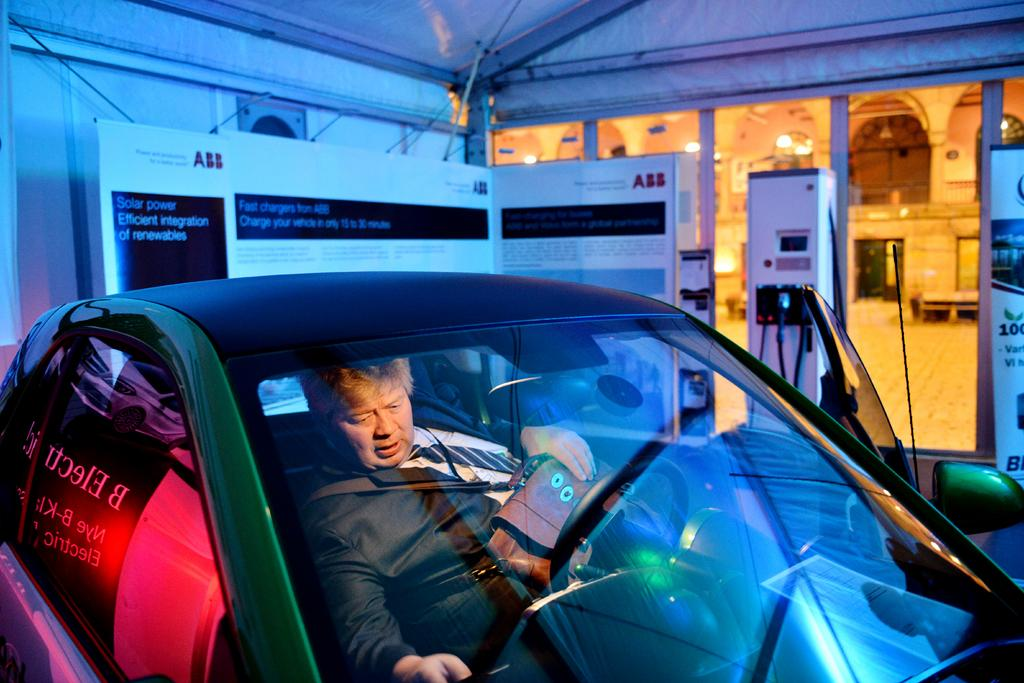What is the main subject of the image? There is a car in the image. Who or what is inside the car? A person is sitting inside the car. What can be seen in the background of the image? There is a board and a building in the background of the image. Can you tell me how many yaks are visible in the image? There are no yaks present in the image. What impulse might the person inside the car be experiencing? The image does not provide any information about the person's emotions or impulses, so we cannot determine what impulse they might be experiencing. 